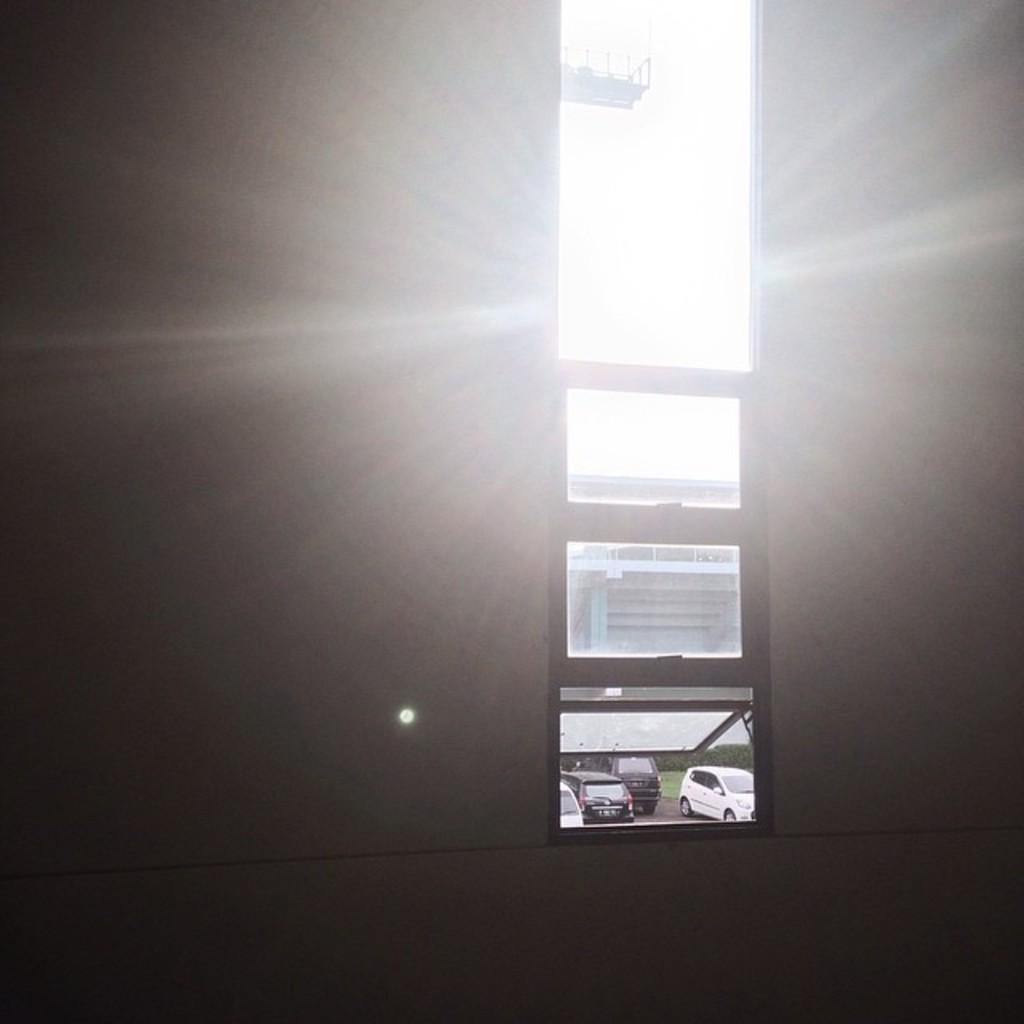What type of structure can be seen in the image? There is a wall, a window, and a building visible in the image. What is parked near the building in the image? There are cars parked near the building in the image. What type of vegetation can be seen in the image? There are plants visible in the image. What part of the building is visible in the image? There is a metal frame from a window in the image. What type of yarn is being used to create the curve in the box in the image? There is no yarn, curve, or box present in the image. 